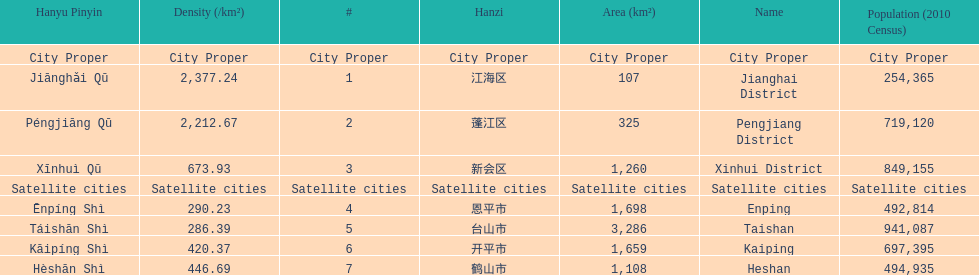Which area has the largest population? Taishan. 